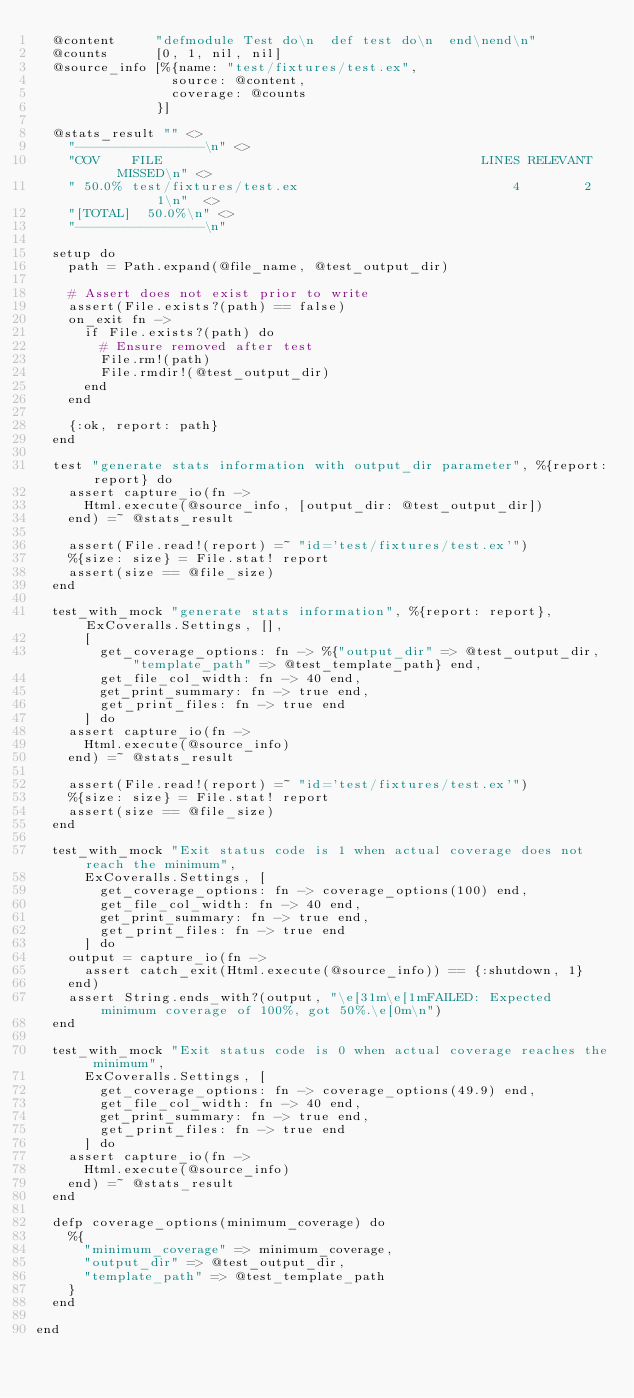<code> <loc_0><loc_0><loc_500><loc_500><_Elixir_>  @content     "defmodule Test do\n  def test do\n  end\nend\n"
  @counts      [0, 1, nil, nil]
  @source_info [%{name: "test/fixtures/test.ex",
                 source: @content,
                 coverage: @counts
               }]

  @stats_result "" <>
    "----------------\n" <>
    "COV    FILE                                        LINES RELEVANT   MISSED\n" <>
    " 50.0% test/fixtures/test.ex                           4        2        1\n"  <>
    "[TOTAL]  50.0%\n" <>
    "----------------\n"

  setup do
    path = Path.expand(@file_name, @test_output_dir)

    # Assert does not exist prior to write
    assert(File.exists?(path) == false)
    on_exit fn ->
      if File.exists?(path) do
        # Ensure removed after test
        File.rm!(path)
        File.rmdir!(@test_output_dir)
      end
    end

    {:ok, report: path}
  end

  test "generate stats information with output_dir parameter", %{report: report} do
    assert capture_io(fn ->
      Html.execute(@source_info, [output_dir: @test_output_dir])
    end) =~ @stats_result

    assert(File.read!(report) =~ "id='test/fixtures/test.ex'")
    %{size: size} = File.stat! report
    assert(size == @file_size)
  end

  test_with_mock "generate stats information", %{report: report}, ExCoveralls.Settings, [],
      [
        get_coverage_options: fn -> %{"output_dir" => @test_output_dir, "template_path" => @test_template_path} end,
        get_file_col_width: fn -> 40 end,
        get_print_summary: fn -> true end,
        get_print_files: fn -> true end
      ] do
    assert capture_io(fn ->
      Html.execute(@source_info)
    end) =~ @stats_result

    assert(File.read!(report) =~ "id='test/fixtures/test.ex'")
    %{size: size} = File.stat! report
    assert(size == @file_size)
  end

  test_with_mock "Exit status code is 1 when actual coverage does not reach the minimum",
      ExCoveralls.Settings, [
        get_coverage_options: fn -> coverage_options(100) end,
        get_file_col_width: fn -> 40 end,
        get_print_summary: fn -> true end,
        get_print_files: fn -> true end
      ] do
    output = capture_io(fn ->
      assert catch_exit(Html.execute(@source_info)) == {:shutdown, 1}
    end)
    assert String.ends_with?(output, "\e[31m\e[1mFAILED: Expected minimum coverage of 100%, got 50%.\e[0m\n")
  end

  test_with_mock "Exit status code is 0 when actual coverage reaches the minimum",
      ExCoveralls.Settings, [
        get_coverage_options: fn -> coverage_options(49.9) end,
        get_file_col_width: fn -> 40 end,
        get_print_summary: fn -> true end,
        get_print_files: fn -> true end
      ] do
    assert capture_io(fn ->
      Html.execute(@source_info)
    end) =~ @stats_result
  end

  defp coverage_options(minimum_coverage) do
    %{
      "minimum_coverage" => minimum_coverage,
      "output_dir" => @test_output_dir,
      "template_path" => @test_template_path
    }
  end

end
</code> 